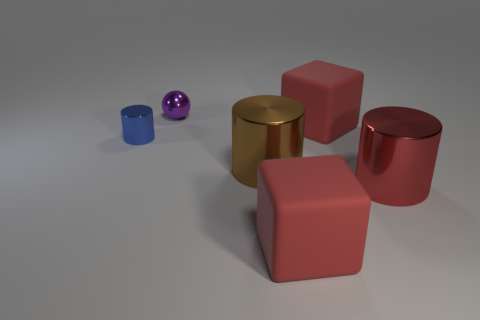What number of purple shiny things have the same shape as the large red metallic object?
Provide a succinct answer. 0. The shiny thing that is the same size as the red metal cylinder is what color?
Your response must be concise. Brown. There is a big object that is right of the big cube behind the red cube that is in front of the big red metallic cylinder; what is its color?
Offer a very short reply. Red. There is a purple metallic sphere; does it have the same size as the metallic cylinder on the left side of the small shiny ball?
Make the answer very short. Yes. How many things are either small yellow cylinders or blue metal things?
Provide a short and direct response. 1. Are there any blocks that have the same material as the brown thing?
Keep it short and to the point. No. There is a large rubber block that is behind the large metal object to the left of the red metallic cylinder; what color is it?
Your answer should be compact. Red. Do the brown shiny thing and the blue metal thing have the same size?
Your answer should be compact. No. What number of cubes are either brown things or blue metallic things?
Make the answer very short. 0. There is a thing that is to the left of the purple sphere; what number of large red rubber things are on the right side of it?
Provide a short and direct response. 2. 